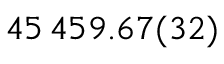<formula> <loc_0><loc_0><loc_500><loc_500>4 5 \, 4 5 9 . 6 7 ( 3 2 )</formula> 